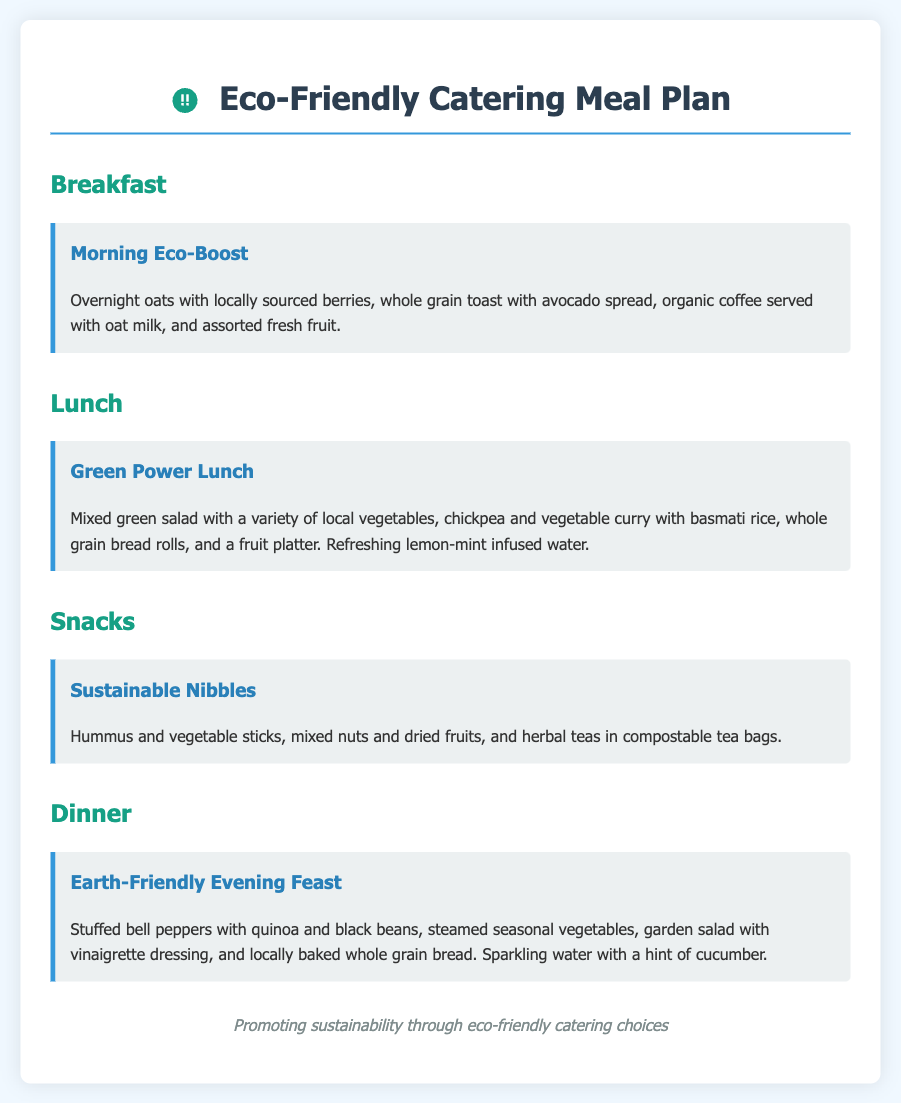what is the title of the document? The title is indicated at the top of the document, which is "Eco-Friendly Catering Meal Plan."
Answer: Eco-Friendly Catering Meal Plan how many sections are there in the meal plan? The meal plan consists of four main sections: Breakfast, Lunch, Snacks, and Dinner.
Answer: Four what dish is included in the Breakfast section? The Breakfast section includes "Morning Eco-Boost," which describes the meal and ingredients.
Answer: Morning Eco-Boost what types of snacks are provided? The Snacks section lists "Sustainable Nibbles," which includes specific items in the description.
Answer: Hummus and vegetable sticks, mixed nuts, and dried fruits what beverage accompanies the Green Power Lunch? The document states that lemon-mint infused water is served with the Green Power Lunch.
Answer: Lemon-mint infused water what is the primary ingredient in the Dinner’s stuffed bell peppers? The Dinner section mentions quinoa and black beans as the primary ingredients in stuffed bell peppers.
Answer: Quinoa and black beans what is the color of the header in the main title? The color of the header in the main title is indicated as #2c3e50.
Answer: #2c3e50 what is used for sweetening the herbal teas? The herbal teas are served in compostable tea bags, with no mention of sweeteners.
Answer: Compostable tea bags 